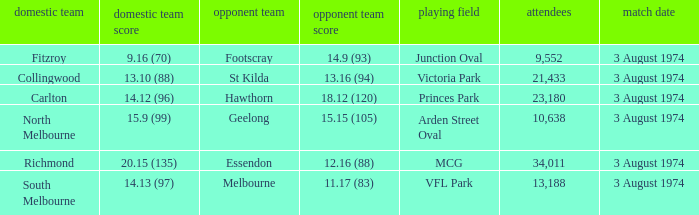Which Home team has a Venue of arden street oval? North Melbourne. 